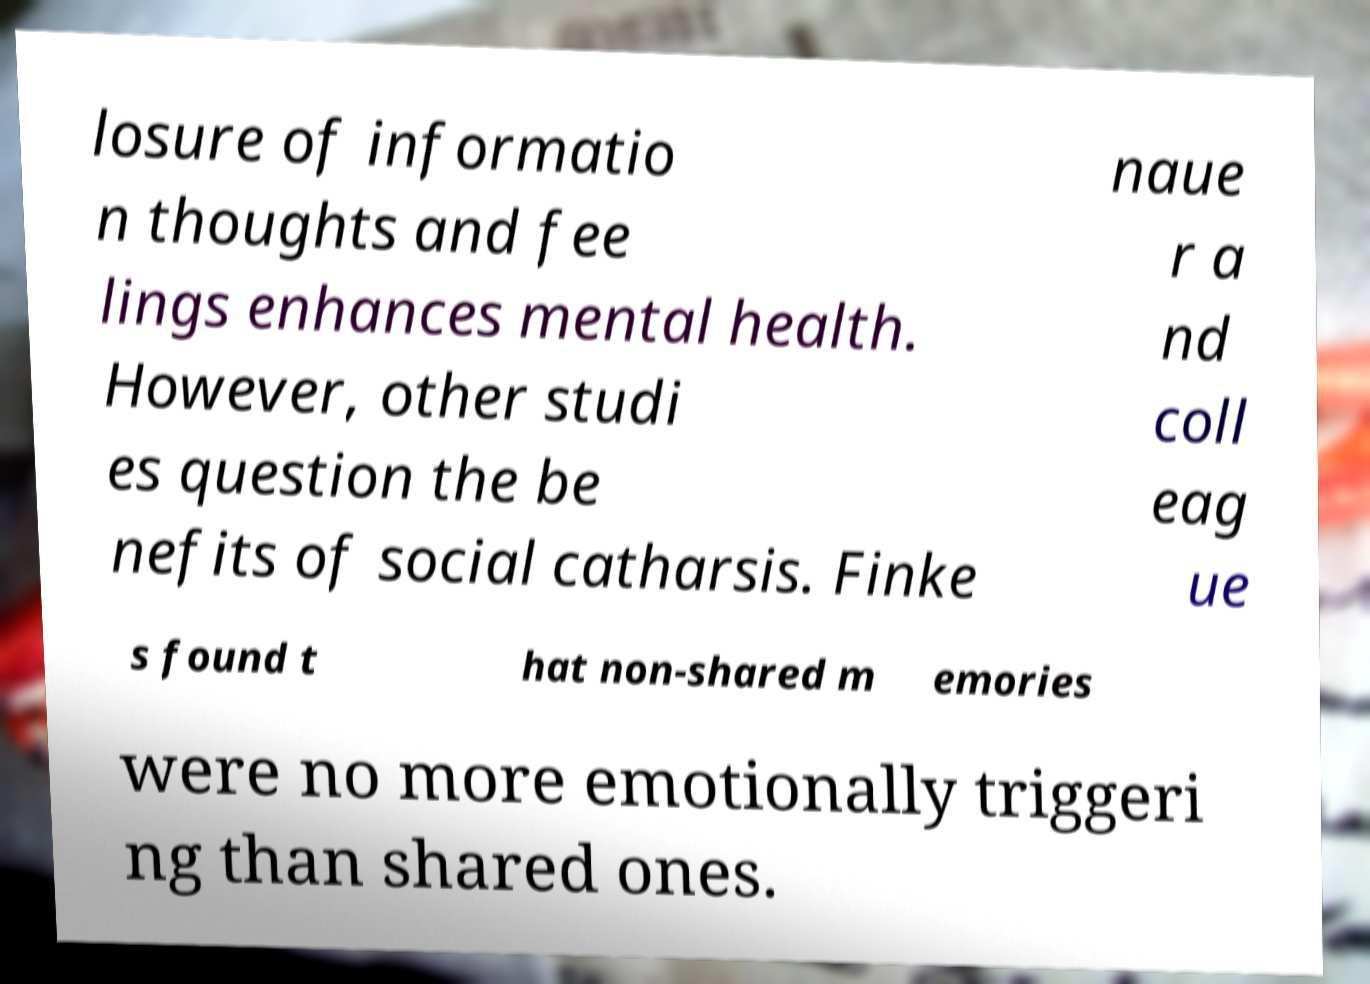Can you read and provide the text displayed in the image?This photo seems to have some interesting text. Can you extract and type it out for me? losure of informatio n thoughts and fee lings enhances mental health. However, other studi es question the be nefits of social catharsis. Finke naue r a nd coll eag ue s found t hat non-shared m emories were no more emotionally triggeri ng than shared ones. 